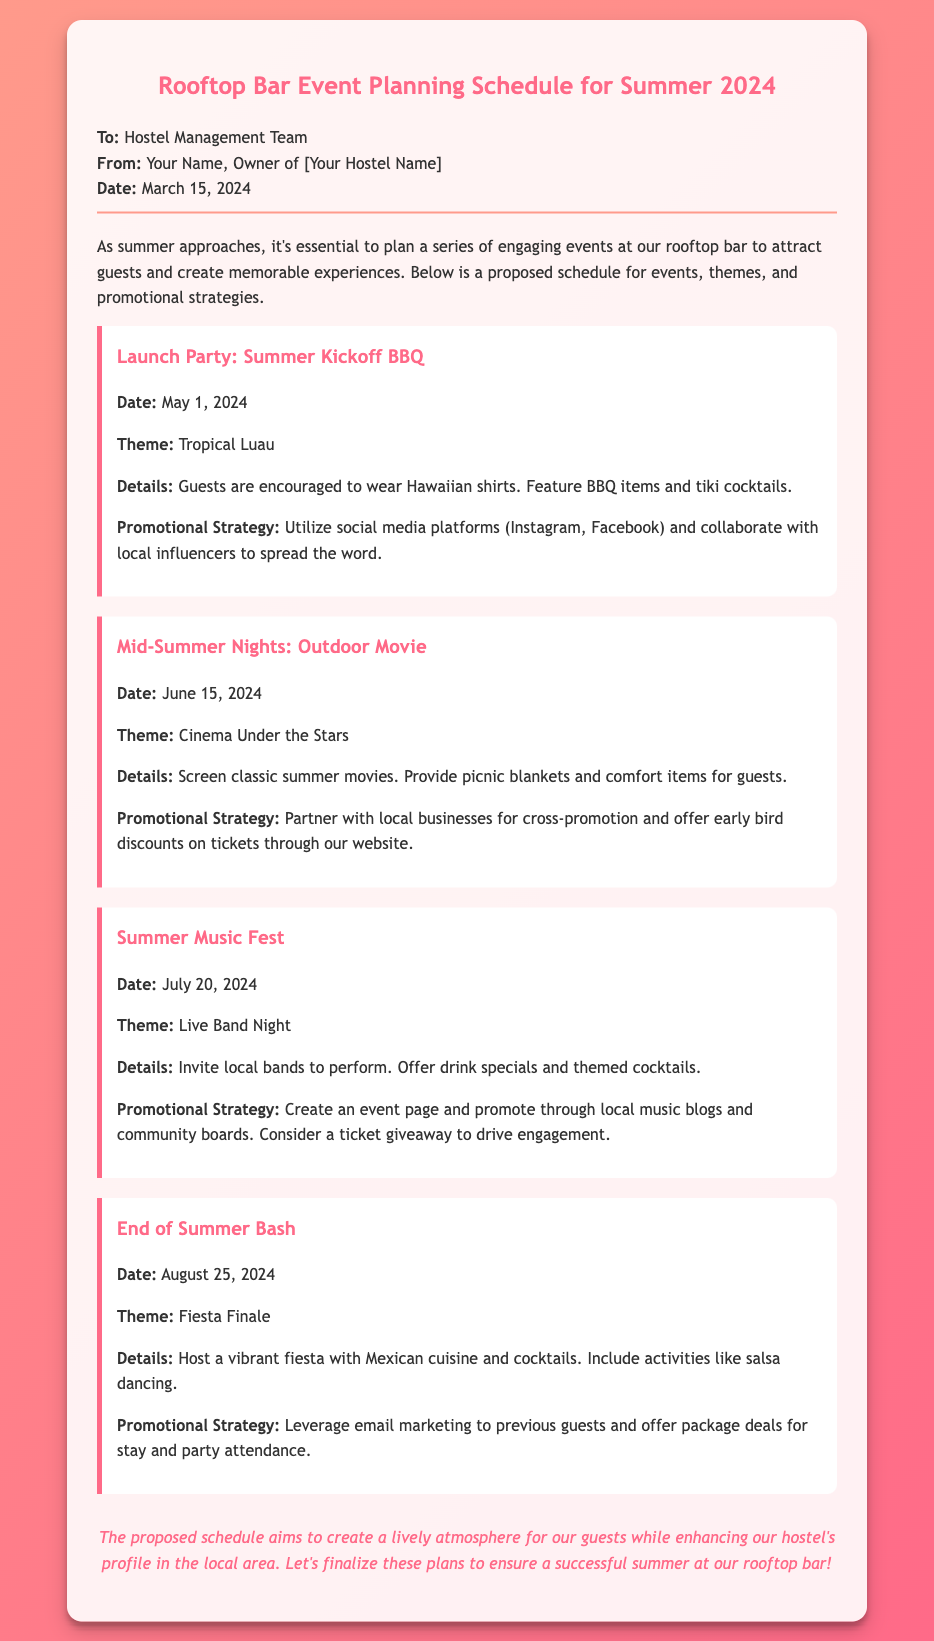What is the date of the Launch Party? The Launch Party is scheduled for May 1, 2024, as indicated in the document.
Answer: May 1, 2024 What is the theme of the End of Summer Bash? The theme for the End of Summer Bash is Fiesta Finale, which is explicitly mentioned in the document.
Answer: Fiesta Finale How many events are planned for the summer season? The memo outlines a total of four events planned for the summer season at the rooftop bar.
Answer: Four What is the proposed promotional strategy for the Mid-Summer Nights event? The promotional strategy for the Mid-Summer Nights event includes partnering with local businesses for cross-promotion.
Answer: Partner with local businesses Which date corresponds to the Summer Music Fest? According to the schedule, the Summer Music Fest is set for July 20, 2024.
Answer: July 20, 2024 What type of cuisine will be served at the End of Summer Bash? The document specifies that Mexican cuisine will be featured at the End of Summer Bash.
Answer: Mexican cuisine What activity is included in the Fiesta Finale event? The Fiesta Finale event includes activities such as salsa dancing, which is mentioned in the details section.
Answer: Salsa dancing What beverage offerings are mentioned for the Summer Music Fest? The document states that drink specials and themed cocktails will be offered during the Summer Music Fest.
Answer: Drink specials and themed cocktails 